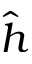Convert formula to latex. <formula><loc_0><loc_0><loc_500><loc_500>\hat { h }</formula> 